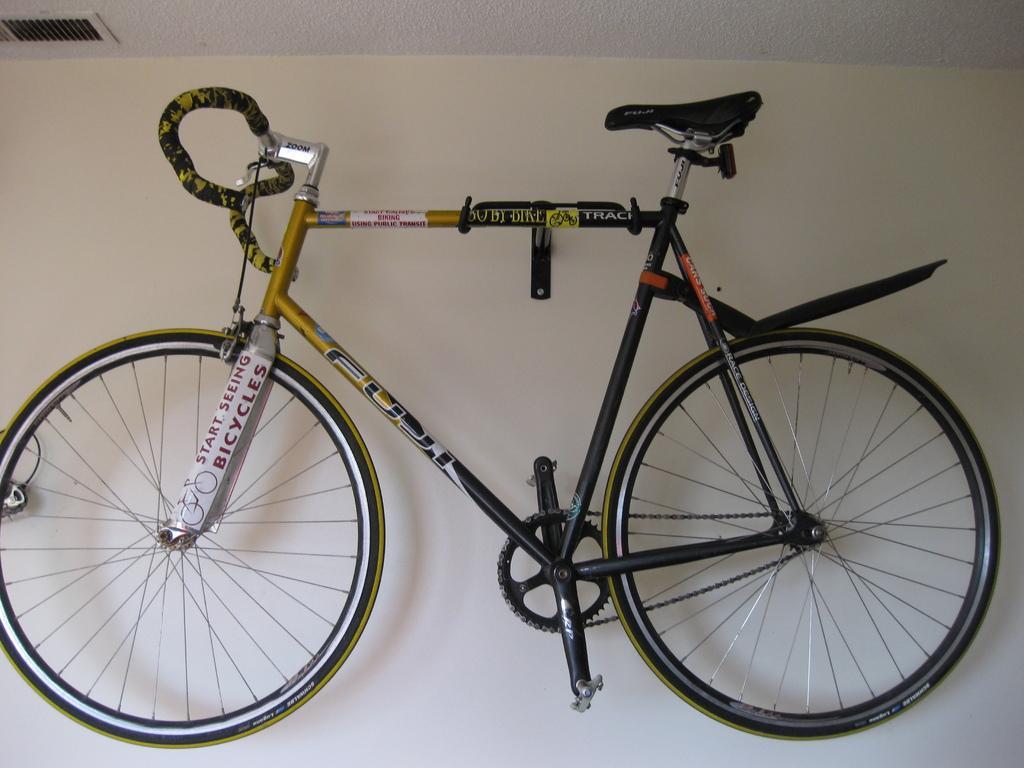Please provide a concise description of this image. In this image there is a bicycle hanging on the wall. 